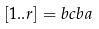Convert formula to latex. <formula><loc_0><loc_0><loc_500><loc_500>[ 1 . . r ] = b c b a</formula> 